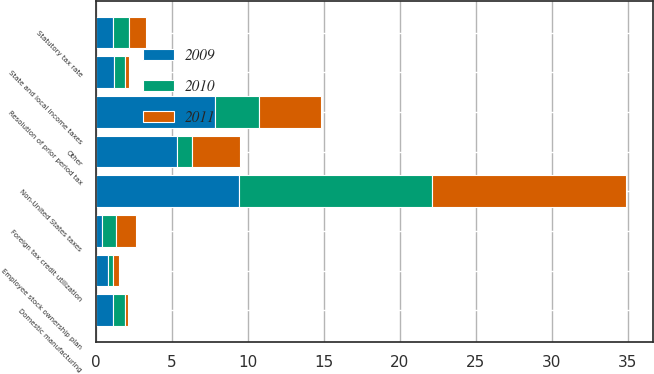Convert chart. <chart><loc_0><loc_0><loc_500><loc_500><stacked_bar_chart><ecel><fcel>Statutory tax rate<fcel>State and local income taxes<fcel>Non-United States taxes<fcel>Foreign tax credit utilization<fcel>Employee stock ownership plan<fcel>Domestic manufacturing<fcel>Resolution of prior period tax<fcel>Other<nl><fcel>2010<fcel>1.1<fcel>0.7<fcel>12.7<fcel>0.9<fcel>0.3<fcel>0.8<fcel>2.9<fcel>1<nl><fcel>2011<fcel>1.1<fcel>0.3<fcel>12.8<fcel>1.3<fcel>0.4<fcel>0.2<fcel>4.1<fcel>3.2<nl><fcel>2009<fcel>1.1<fcel>1.2<fcel>9.4<fcel>0.4<fcel>0.8<fcel>1.1<fcel>7.8<fcel>5.3<nl></chart> 